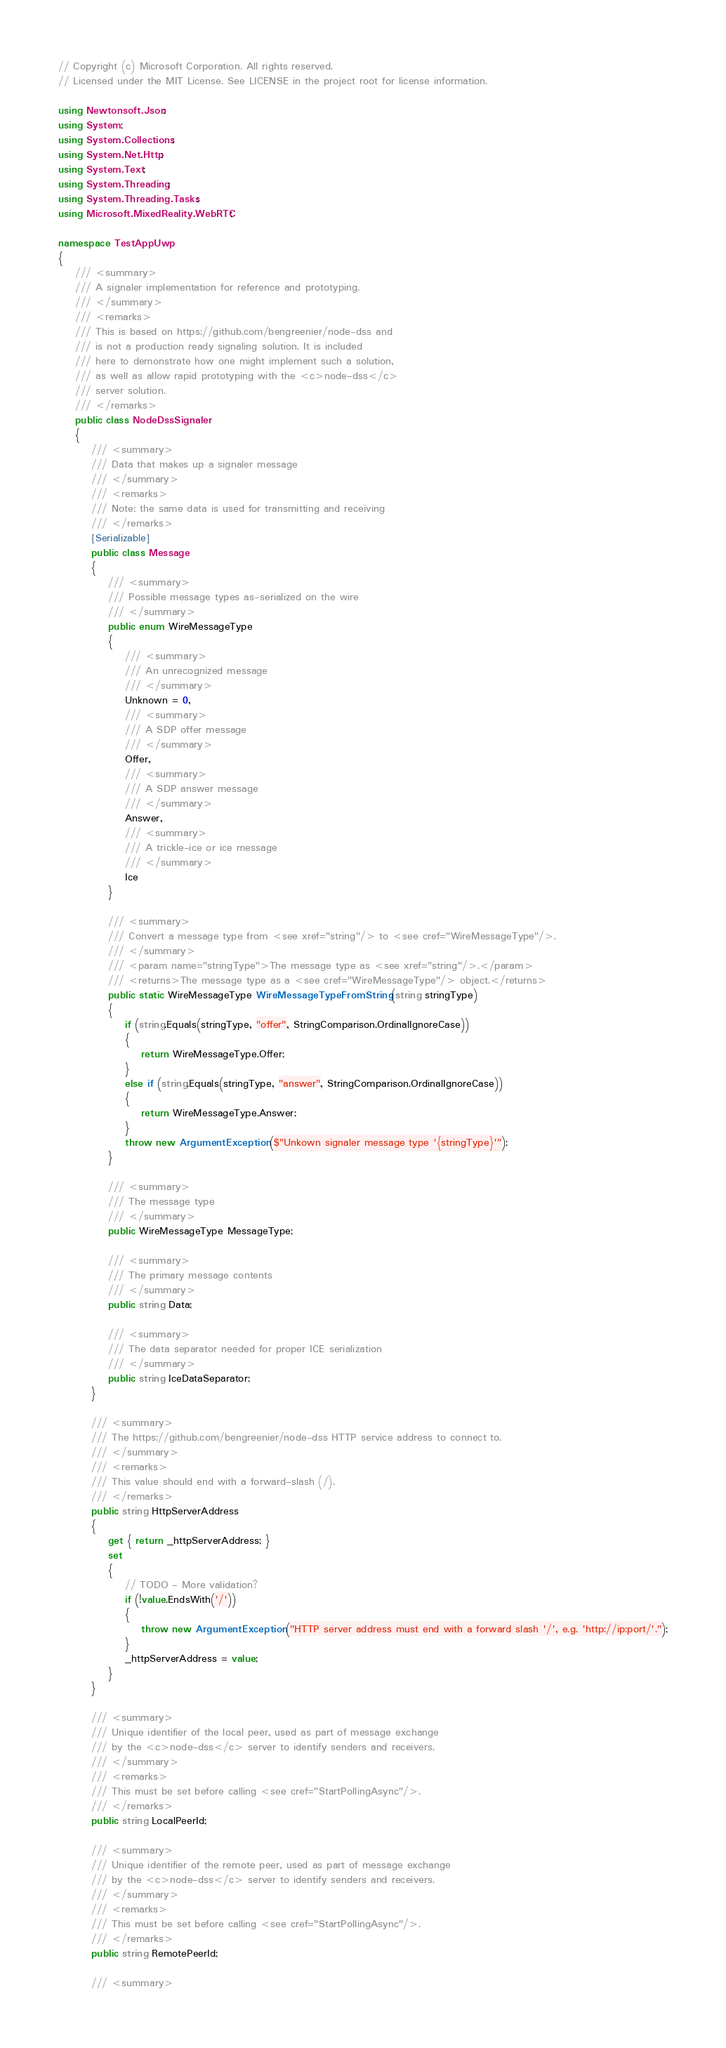Convert code to text. <code><loc_0><loc_0><loc_500><loc_500><_C#_>// Copyright (c) Microsoft Corporation. All rights reserved.
// Licensed under the MIT License. See LICENSE in the project root for license information.

using Newtonsoft.Json;
using System;
using System.Collections;
using System.Net.Http;
using System.Text;
using System.Threading;
using System.Threading.Tasks;
using Microsoft.MixedReality.WebRTC;

namespace TestAppUwp
{
    /// <summary>
    /// A signaler implementation for reference and prototyping.
    /// </summary>
    /// <remarks>
    /// This is based on https://github.com/bengreenier/node-dss and
    /// is not a production ready signaling solution. It is included
    /// here to demonstrate how one might implement such a solution,
    /// as well as allow rapid prototyping with the <c>node-dss</c>
    /// server solution.
    /// </remarks>
    public class NodeDssSignaler
    {
        /// <summary>
        /// Data that makes up a signaler message
        /// </summary>
        /// <remarks>
        /// Note: the same data is used for transmitting and receiving
        /// </remarks>
        [Serializable]
        public class Message
        {
            /// <summary>
            /// Possible message types as-serialized on the wire
            /// </summary>
            public enum WireMessageType
            {
                /// <summary>
                /// An unrecognized message
                /// </summary>
                Unknown = 0,
                /// <summary>
                /// A SDP offer message
                /// </summary>
                Offer,
                /// <summary>
                /// A SDP answer message
                /// </summary>
                Answer,
                /// <summary>
                /// A trickle-ice or ice message
                /// </summary>
                Ice
            }

            /// <summary>
            /// Convert a message type from <see xref="string"/> to <see cref="WireMessageType"/>.
            /// </summary>
            /// <param name="stringType">The message type as <see xref="string"/>.</param>
            /// <returns>The message type as a <see cref="WireMessageType"/> object.</returns>
            public static WireMessageType WireMessageTypeFromString(string stringType)
            {
                if (string.Equals(stringType, "offer", StringComparison.OrdinalIgnoreCase))
                {
                    return WireMessageType.Offer;
                }
                else if (string.Equals(stringType, "answer", StringComparison.OrdinalIgnoreCase))
                {
                    return WireMessageType.Answer;
                }
                throw new ArgumentException($"Unkown signaler message type '{stringType}'");
            }

            /// <summary>
            /// The message type
            /// </summary>
            public WireMessageType MessageType;

            /// <summary>
            /// The primary message contents
            /// </summary>
            public string Data;

            /// <summary>
            /// The data separator needed for proper ICE serialization
            /// </summary>
            public string IceDataSeparator;
        }

        /// <summary>
        /// The https://github.com/bengreenier/node-dss HTTP service address to connect to.
        /// </summary>
        /// <remarks>
        /// This value should end with a forward-slash (/).
        /// </remarks>
        public string HttpServerAddress
        {
            get { return _httpServerAddress; }
            set
            {
                // TODO - More validation?
                if (!value.EndsWith('/'))
                {
                    throw new ArgumentException("HTTP server address must end with a forward slash '/', e.g. 'http://ip:port/'.");
                }
                _httpServerAddress = value;
            }
        }

        /// <summary>
        /// Unique identifier of the local peer, used as part of message exchange
        /// by the <c>node-dss</c> server to identify senders and receivers.
        /// </summary>
        /// <remarks>
        /// This must be set before calling <see cref="StartPollingAsync"/>.
        /// </remarks>
        public string LocalPeerId;

        /// <summary>
        /// Unique identifier of the remote peer, used as part of message exchange
        /// by the <c>node-dss</c> server to identify senders and receivers.
        /// </summary>
        /// <remarks>
        /// This must be set before calling <see cref="StartPollingAsync"/>.
        /// </remarks>
        public string RemotePeerId;

        /// <summary></code> 